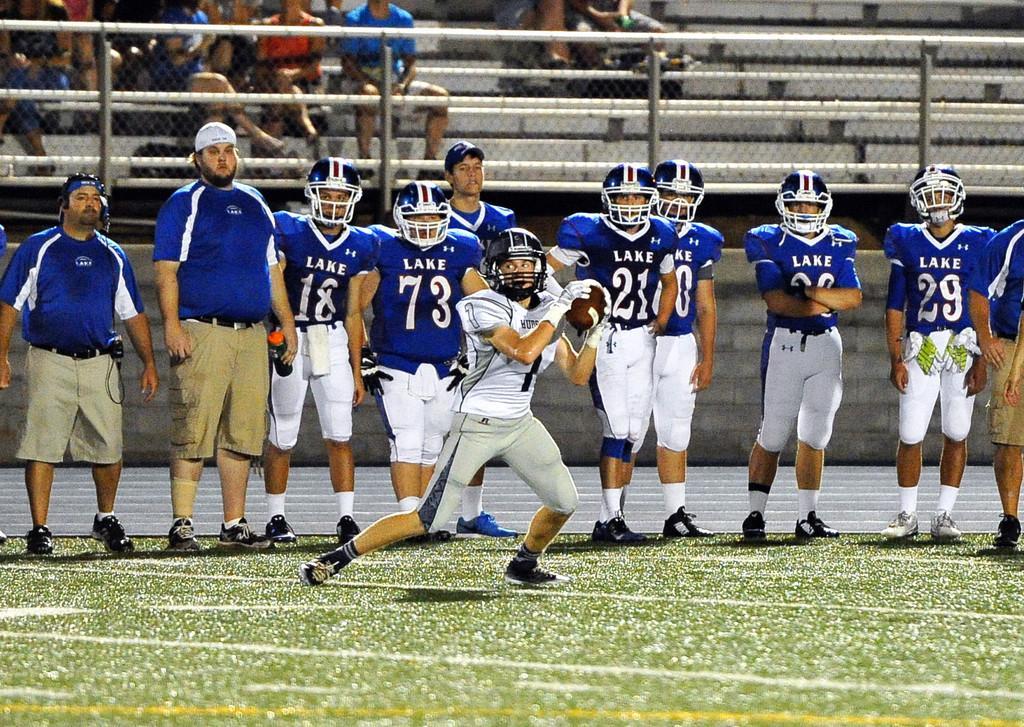Could you give a brief overview of what you see in this image? In this picture we can see a man wore a helmet, gloves, shoes and holding a ball with his hands and at the back of him we can see a group of people standing on the ground and a man holding a bottle with his hand and in the background we can see the wall, fence and some people sitting on steps. 